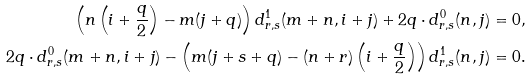<formula> <loc_0><loc_0><loc_500><loc_500>\left ( n \left ( i + \frac { q } { 2 } \right ) - m ( j + q ) \right ) d ^ { 1 } _ { r , s } ( m + n , i + j ) + 2 q \cdot d ^ { 0 } _ { r , s } ( n , j ) & = 0 , \\ 2 q \cdot d ^ { 0 } _ { r , s } ( m + n , i + j ) - \left ( m ( j + s + q ) - ( n + r ) \left ( i + \frac { q } { 2 } \right ) \right ) d ^ { 1 } _ { r , s } ( n , j ) & = 0 .</formula> 